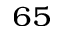Convert formula to latex. <formula><loc_0><loc_0><loc_500><loc_500>_ { 6 5 }</formula> 